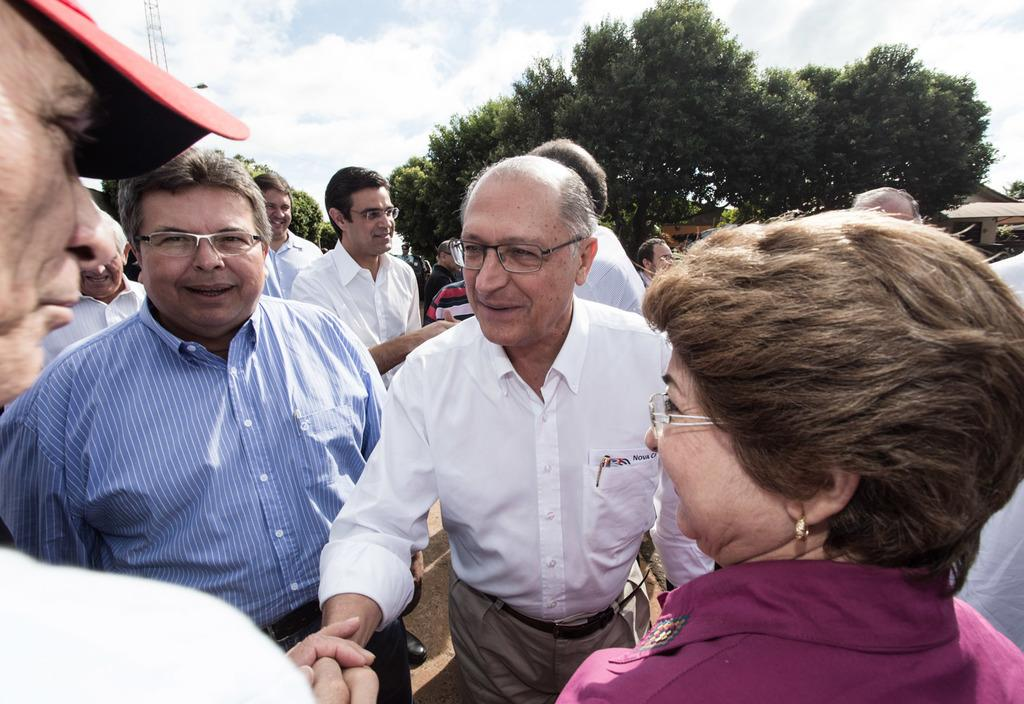What is the primary subject of the image? There are many men standing on the land in the image. Can you describe the woman in the image? There is a woman on the right side of the image. What can be seen in the background of the image? There are trees in the background of the image. What is visible in the sky in the image? The sky is visible in the image, and clouds are present. What type of insurance policy is being discussed by the men in the image? There is no indication in the image that the men are discussing any insurance policies. 